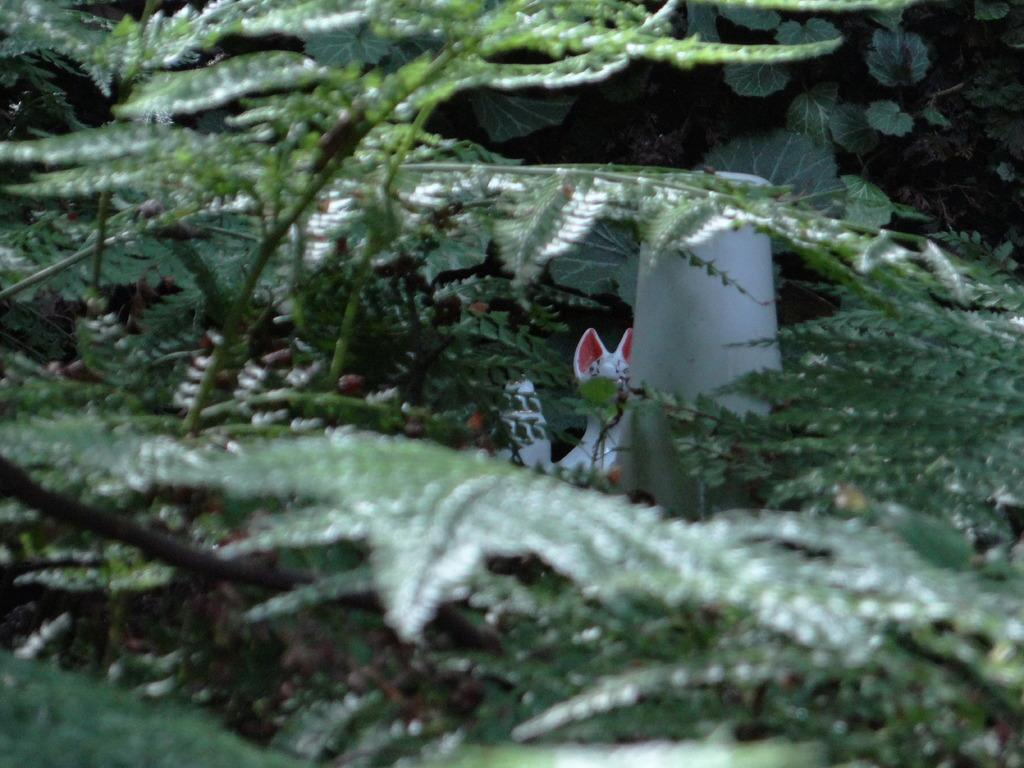What type of vegetation can be seen in the image? There are trees in the image. Can you describe any specific features of the trees? There are leaves visible on the trees in the image. What type of business is being conducted in the image? There is no indication of any business being conducted in the image; it primarily features trees and leaves. 